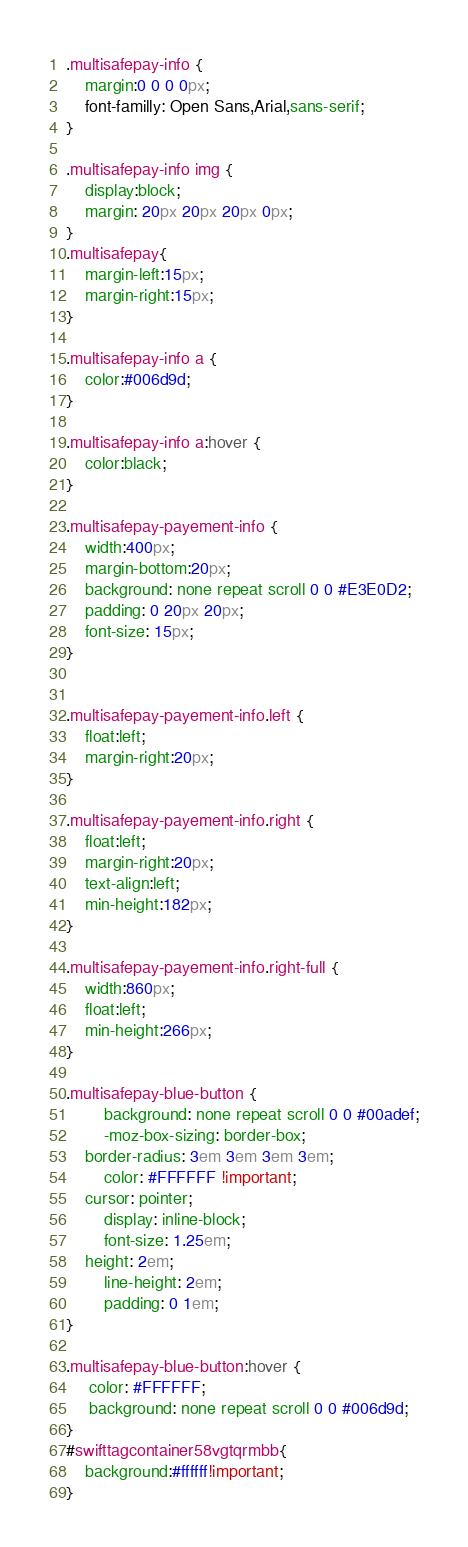Convert code to text. <code><loc_0><loc_0><loc_500><loc_500><_CSS_>.multisafepay-info { 
    margin:0 0 0 0px; 
    font-familly: Open Sans,Arial,sans-serif; 
}

.multisafepay-info img { 
    display:block; 
    margin: 20px 20px 20px 0px; 
}
.multisafepay{
    margin-left:15px;
    margin-right:15px;
}
    
.multisafepay-info a {
    color:#006d9d;
}
    
.multisafepay-info a:hover {
    color:black;
}
    
.multisafepay-payement-info { 
    width:400px; 
    margin-bottom:20px; 
    background: none repeat scroll 0 0 #E3E0D2; 
    padding: 0 20px 20px; 
    font-size: 15px;
}


.multisafepay-payement-info.left { 
    float:left; 
    margin-right:20px; 
}

.multisafepay-payement-info.right { 
    float:left; 
    margin-right:20px; 
    text-align:left; 
    min-height:182px;
}

.multisafepay-payement-info.right-full {
    width:860px;
    float:left;
    min-height:266px;
}

.multisafepay-blue-button {
        background: none repeat scroll 0 0 #00adef;
        -moz-box-sizing: border-box;
    border-radius: 3em 3em 3em 3em;
        color: #FFFFFF !important;
    cursor: pointer;
        display: inline-block;
        font-size: 1.25em;
    height: 2em;
        line-height: 2em;
        padding: 0 1em;
}

.multisafepay-blue-button:hover {
     color: #FFFFFF;
     background: none repeat scroll 0 0 #006d9d;
}
#swifttagcontainer58vgtqrmbb{
    background:#ffffff!important;
}</code> 